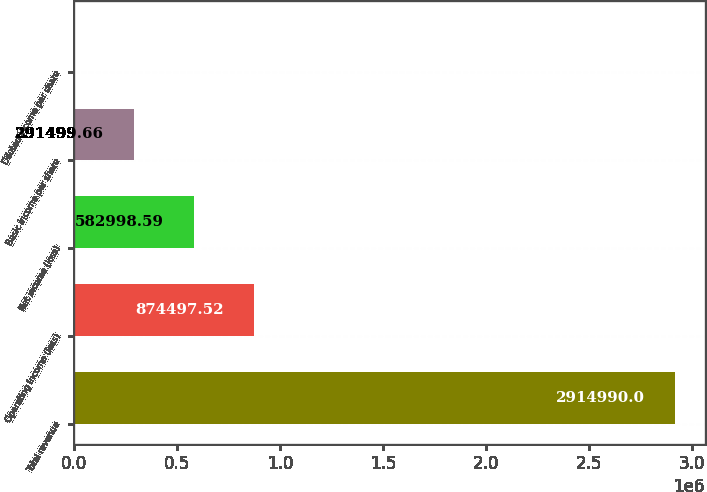Convert chart to OTSL. <chart><loc_0><loc_0><loc_500><loc_500><bar_chart><fcel>Total revenue<fcel>Operating income (loss)<fcel>Net income (loss)<fcel>Basic income per share<fcel>Diluted income per share<nl><fcel>2.91499e+06<fcel>874498<fcel>582999<fcel>291500<fcel>0.73<nl></chart> 